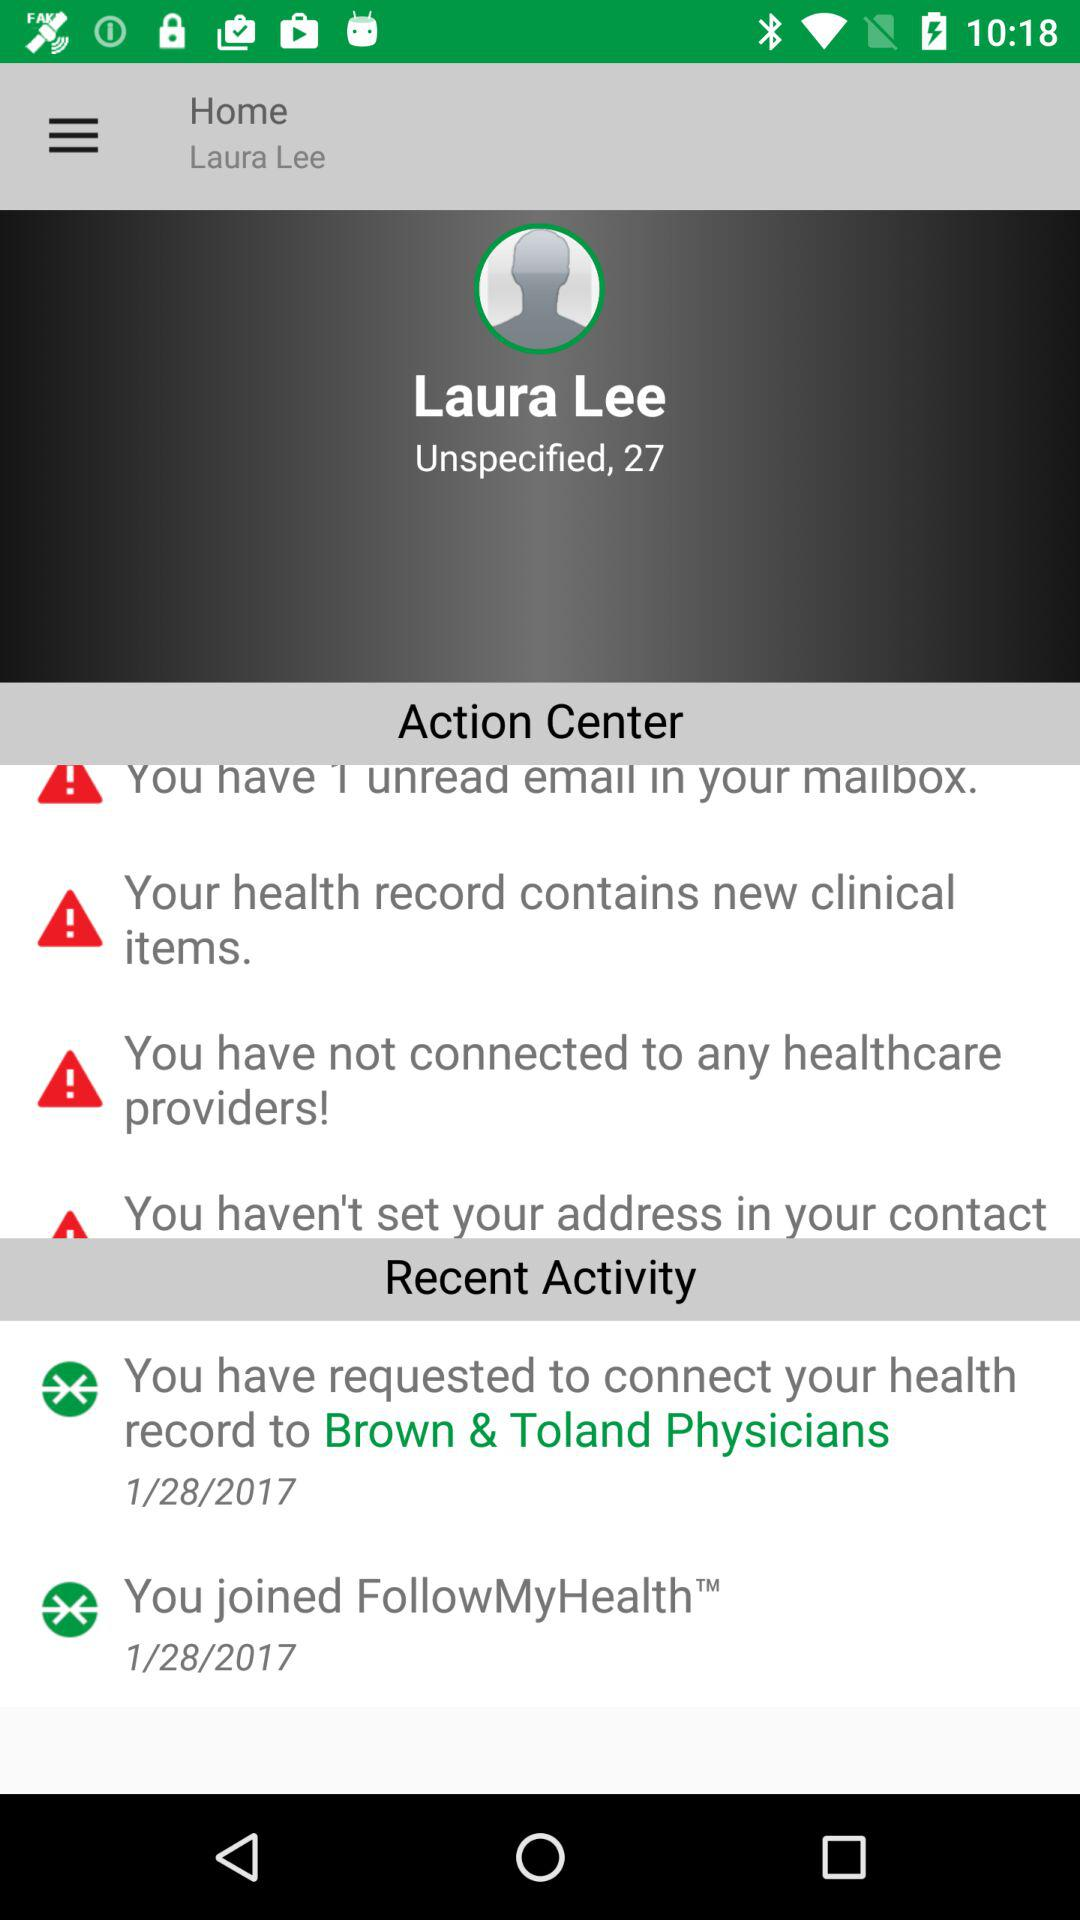To whom does the user need to connect for health records? The user needs to connect to "Brown & Toland Physicians" for health records. 